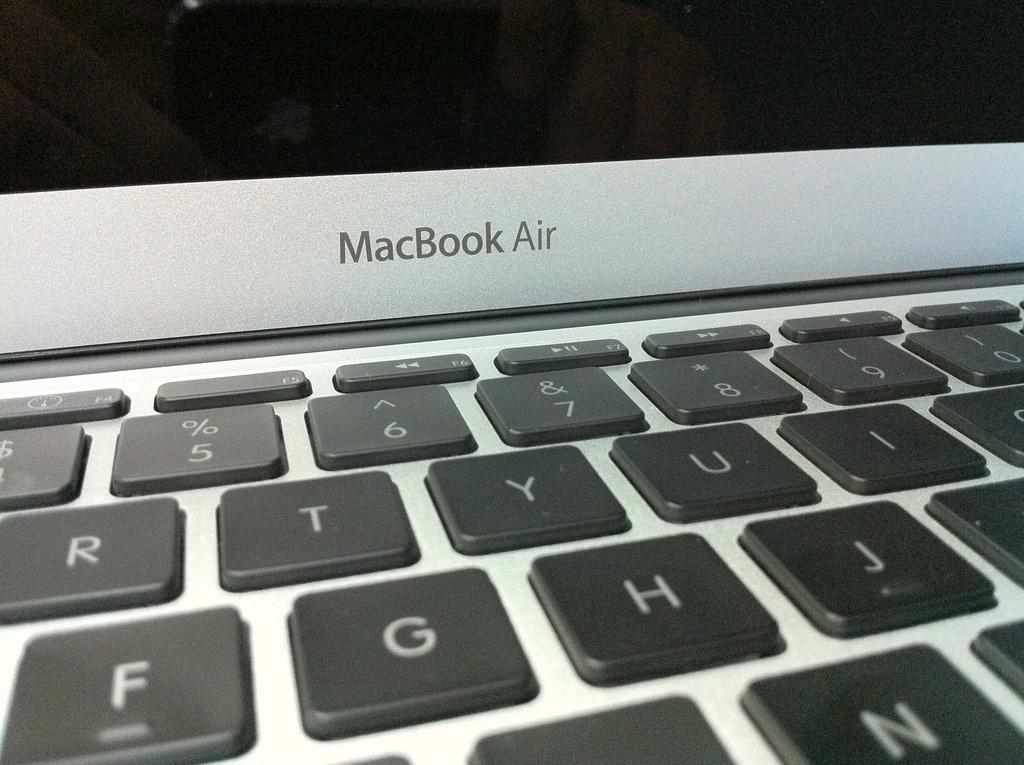<image>
Describe the image concisely. a laptop that has a label on it that said 'macbook air' 